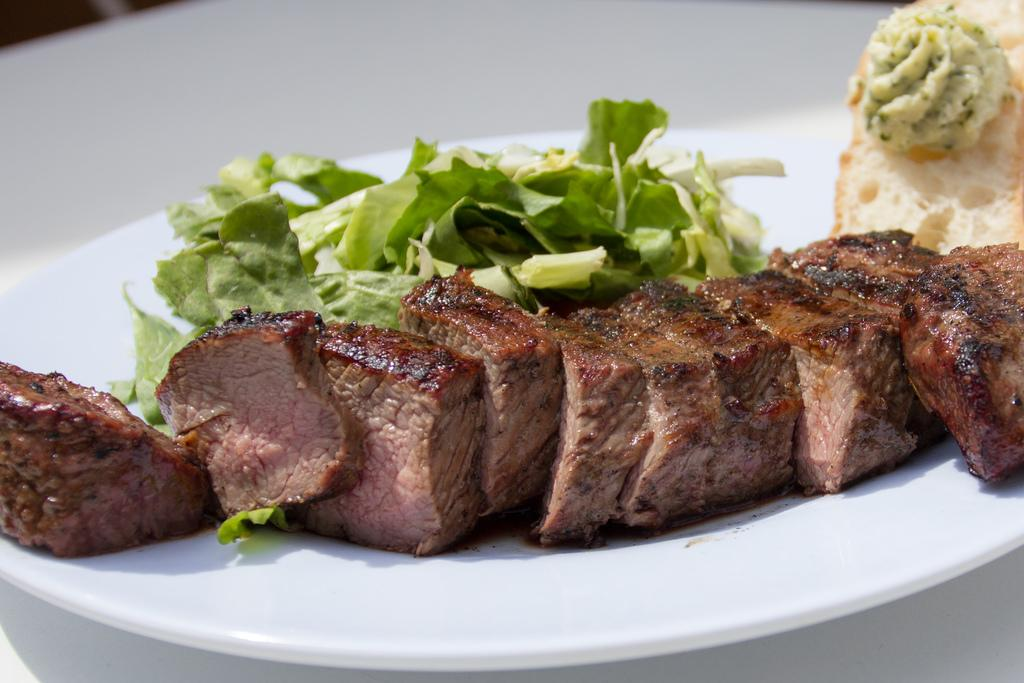What can be seen in the image? There are food items in the image. How are the food items arranged or presented? The food items are placed on a white plate. What type of pancake is being served on the bed in the image? There is no pancake or bed present in the image; it only features food items placed on a white plate. 